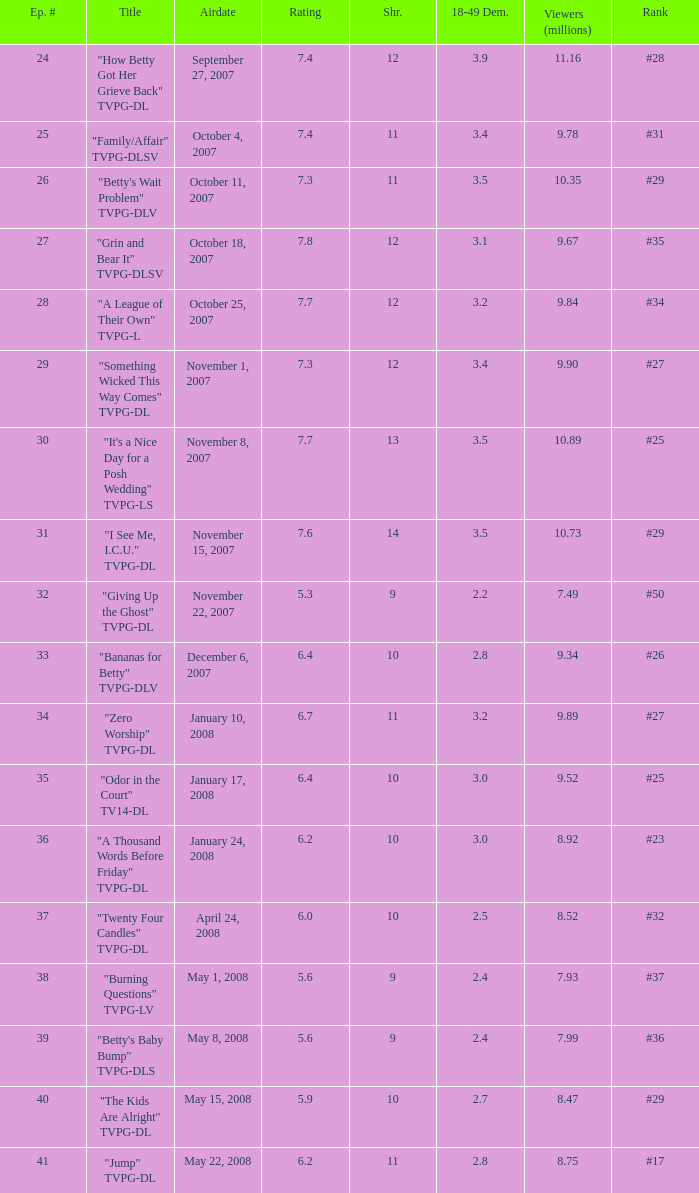What is the Airdate of the episode that ranked #29 and had a share greater than 10? May 15, 2008. 